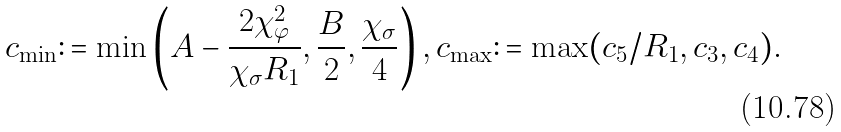Convert formula to latex. <formula><loc_0><loc_0><loc_500><loc_500>c _ { \min } \colon = \min \left ( A - \frac { 2 \chi _ { \varphi } ^ { 2 } } { \chi _ { \sigma } R _ { 1 } } , \frac { B } { 2 } , \frac { \chi _ { \sigma } } { 4 } \right ) , c _ { \max } \colon = \max ( c _ { 5 } / R _ { 1 } , c _ { 3 } , c _ { 4 } ) .</formula> 